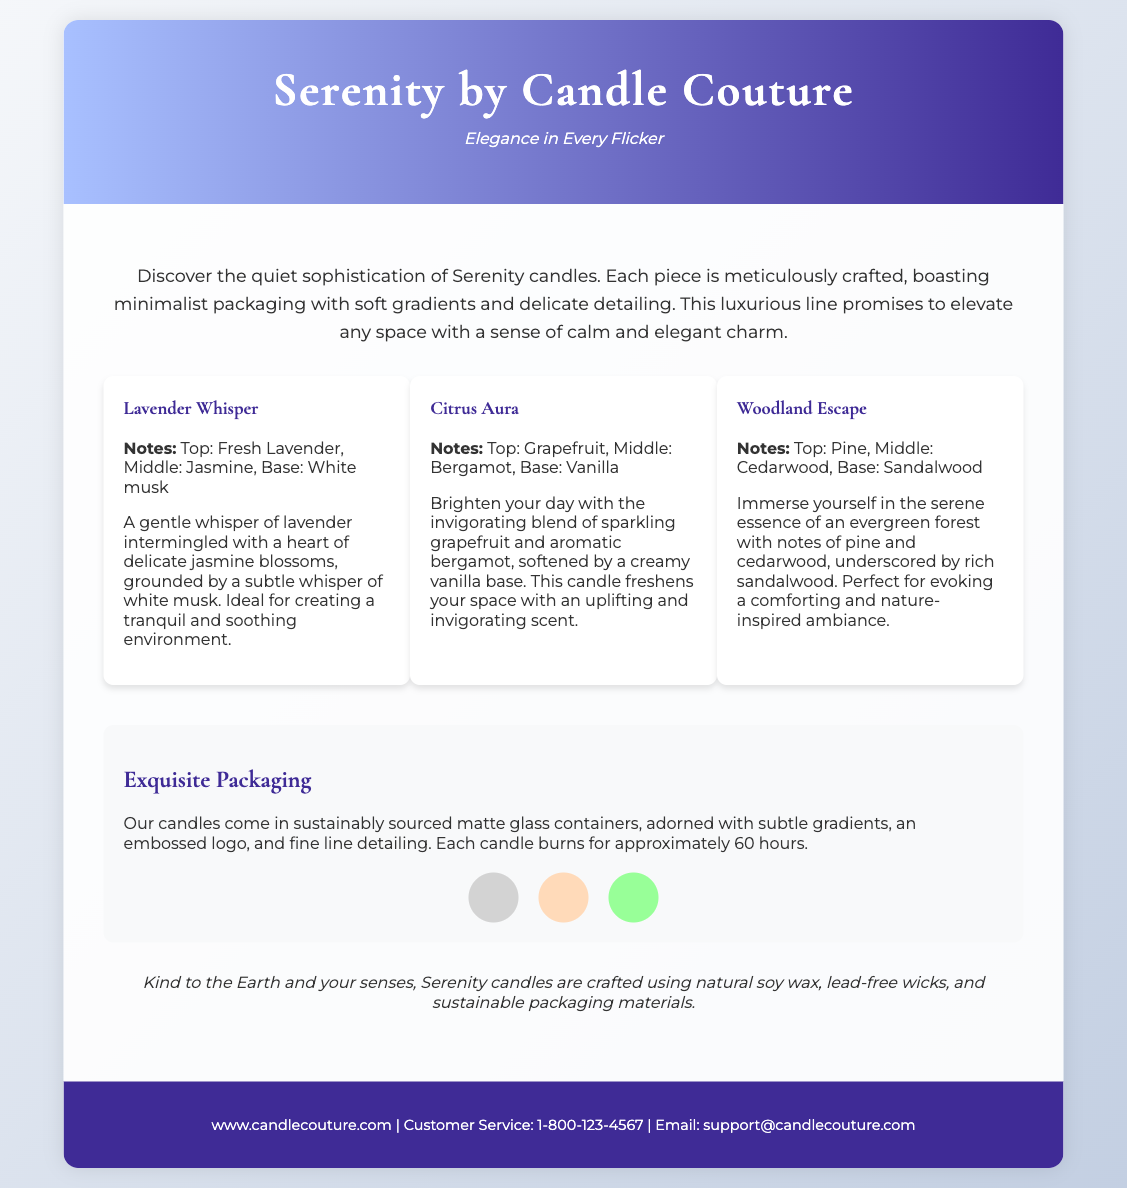what is the name of the candle line? The document features a product line named "Serenity by Candle Couture."
Answer: Serenity by Candle Couture what is the tagline for the product? The tagline provided in the document is "Elegance in Every Flicker."
Answer: Elegance in Every Flicker how long do the candles burn? The document states that each candle burns for approximately 60 hours.
Answer: 60 hours what are the notes of the Lavender Whisper candle? The notes listed for Lavender Whisper include Fresh Lavender, Jasmine, and White musk.
Answer: Fresh Lavender, Jasmine, White musk what type of wax is used in the candles? The document mentions that the candles are crafted using natural soy wax.
Answer: natural soy wax what is the color of the first color swatch? The first color swatch in the document is described as light grey, with the hex equivalent being #D3D3D3.
Answer: light grey what do the candles' packaging features include? The packaging features listed include sustainably sourced matte glass containers, subtle gradients, embossed logo, and fine line detailing.
Answer: sustainably sourced matte glass containers, subtle gradients, embossed logo, fine line detailing what is the main theme of the product's description? The main theme conveyed in the description is "quiet sophistication" and an evocation of calm and elegance.
Answer: quiet sophistication which aroma profile is associated with an evergreen forest? The aroma profile that evokes an evergreen forest is named "Woodland Escape."
Answer: Woodland Escape 